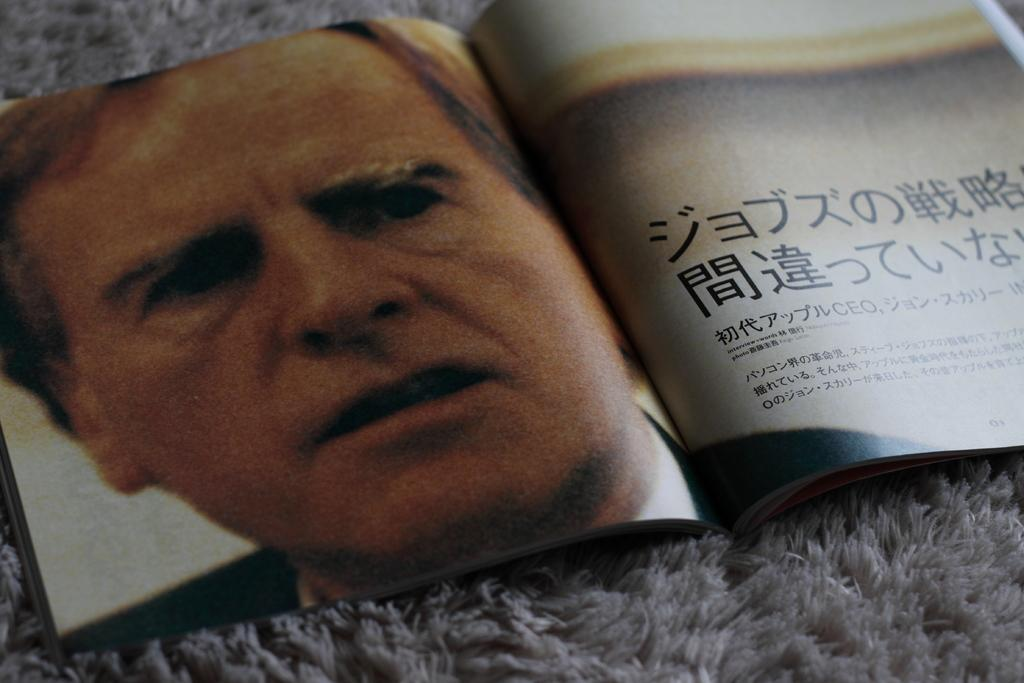What object is present on the white cloth in the image? There is a book on a white cloth in the image. What is the color of the cloth the book is placed on? The cloth is white. Can you describe the person in the image? There is a person in the image, but no specific details about their appearance are provided. What can be seen inside the book? There is writing visible in the book. What type of clouds can be seen in the image? There are no clouds visible in the image; it features a book on a white cloth with a person nearby. Is the book a work of fiction or non-fiction? The type of book, whether fiction or non-fiction, cannot be determined from the image alone. 